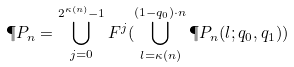<formula> <loc_0><loc_0><loc_500><loc_500>\P P _ { n } = \bigcup _ { j = 0 } ^ { 2 ^ { \kappa ( n ) } - 1 } F ^ { j } ( \bigcup _ { l = \kappa ( n ) } ^ { ( 1 - q _ { 0 } ) \cdot n } \P P _ { n } ( l ; q _ { 0 } , q _ { 1 } ) )</formula> 